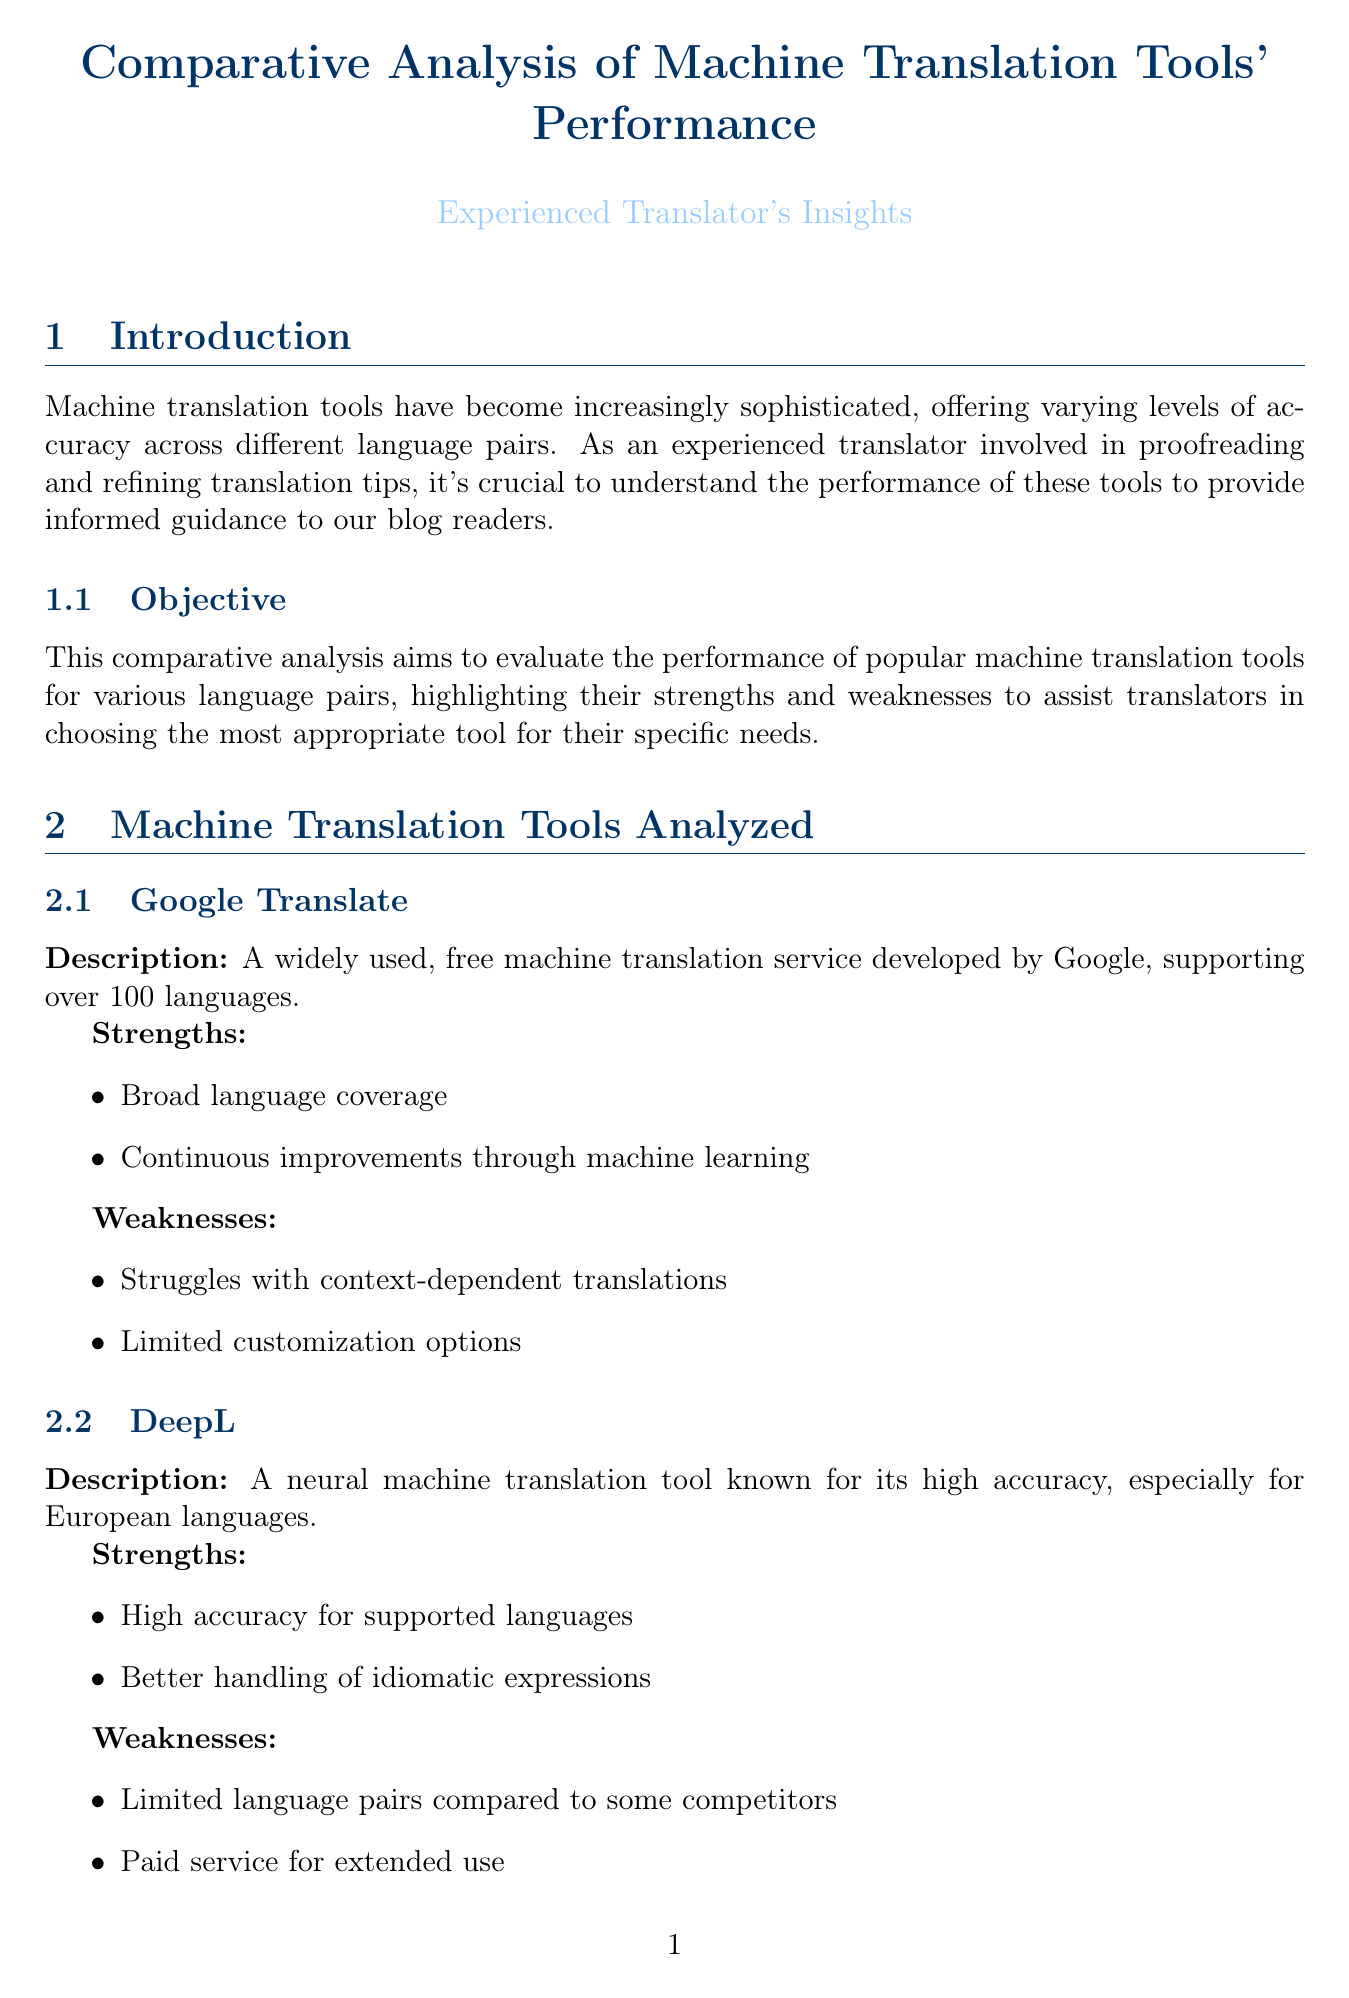What is the objective of the analysis? The objective of the analysis is to evaluate the performance of popular machine translation tools for various language pairs, highlighting their strengths and weaknesses.
Answer: Evaluate performance of machine translation tools Which tool showed superior performance for European language pairs? The overall performance summary states that DeepL showed superior performance for European language pairs.
Answer: DeepL What language pair is critical for international trade? The document states that English-Mandarin Chinese is critical for international trade and cultural exchange.
Answer: English-Mandarin Chinese Which translation tool is known for its high accuracy, especially for European languages? The description of DeepL mentions that it is a neural machine translation tool known for its high accuracy, especially for European languages.
Answer: DeepL What evaluation criteria focuses on cultural nuances? One of the evaluation criteria in the document mentions handling of idiomatic expressions and cultural nuances.
Answer: Handling of idiomatic expressions and cultural nuances What is a weakness of Google Translate? The document lists "struggles with context-dependent translations" as a weakness of Google Translate.
Answer: Struggles with context-dependent translations What type of texts were used in the comparative analysis? The methodology section lists news articles, technical documents, literary excerpts, and legal texts as the types of texts used.
Answer: News articles, technical documents, literary excerpts, legal texts What implication is suggested for Japanese-English translations? The implications for translators suggest considering Microsoft Translator for Japanese-English translations, especially within the Microsoft ecosystem.
Answer: Consider Microsoft Translator for Japanese-English translations 